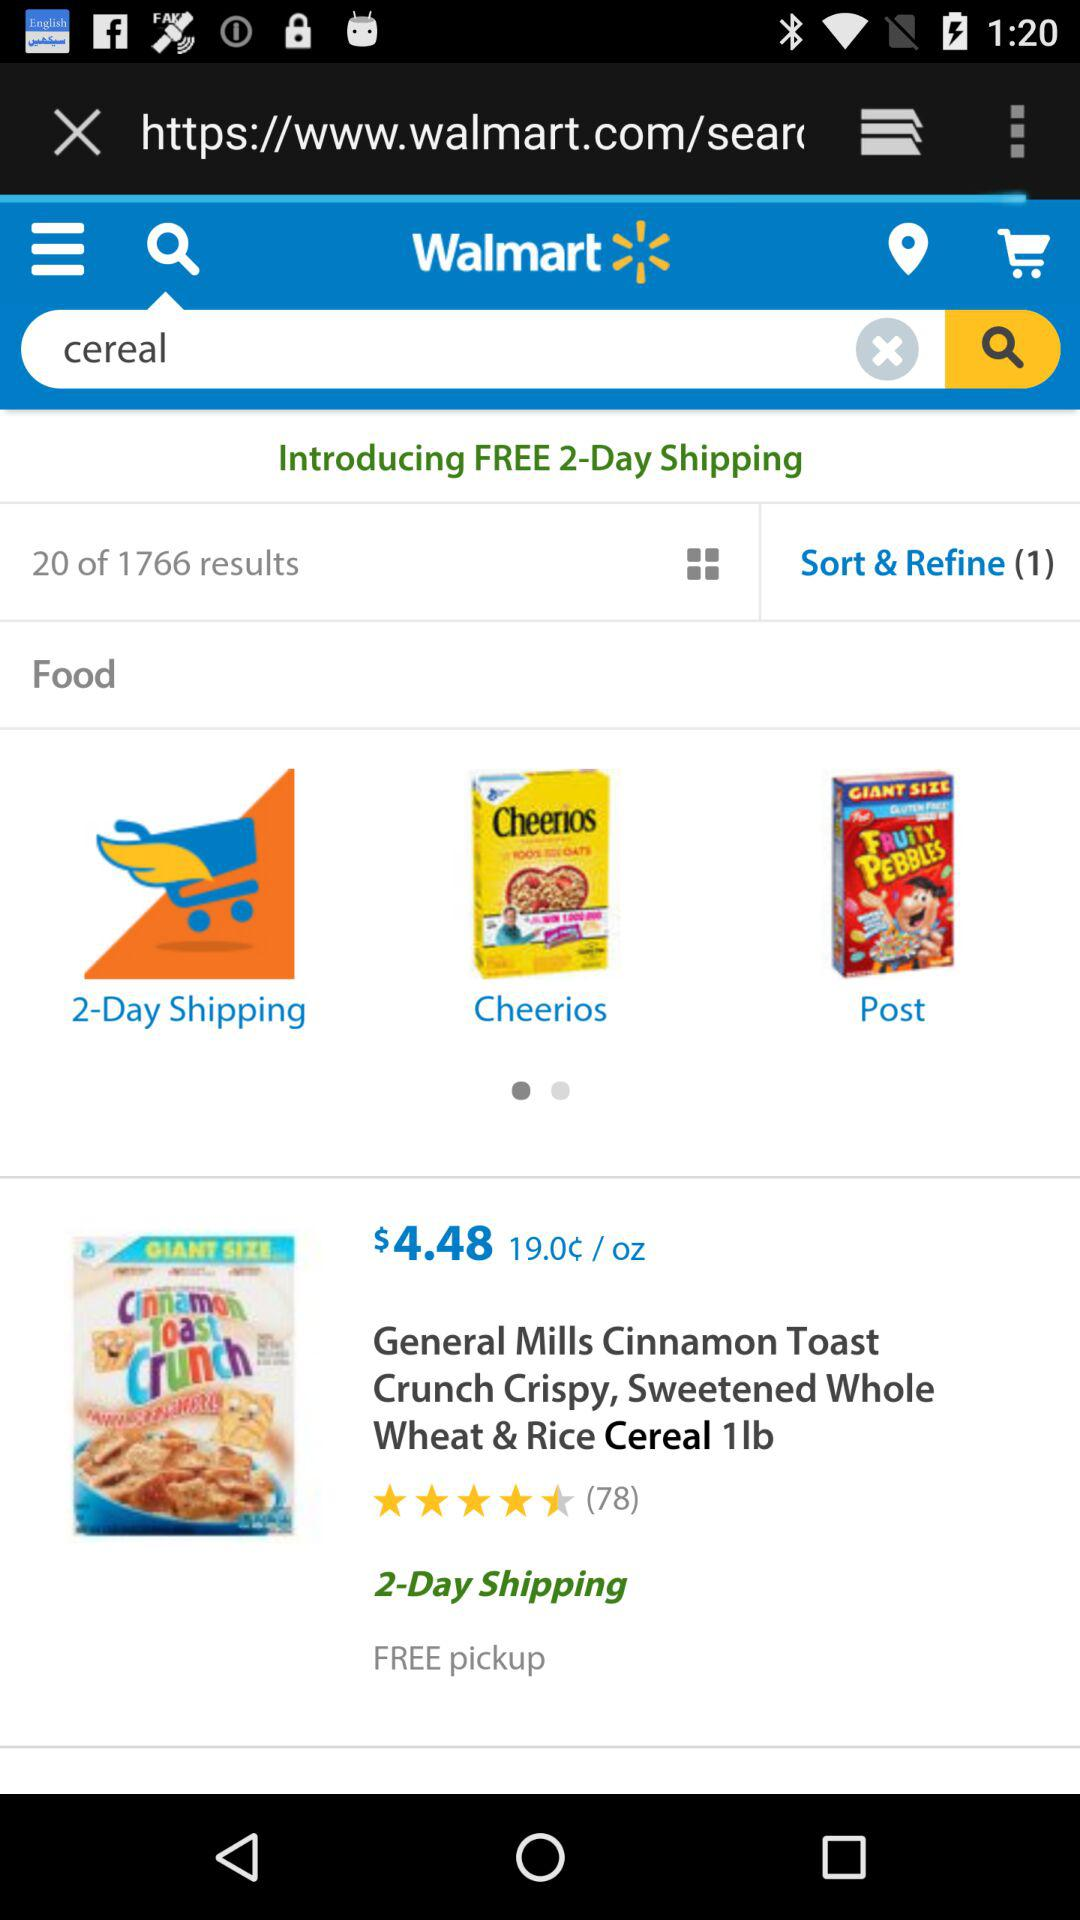What's the price of an ounce of cereal? The price is 19.0¢. 